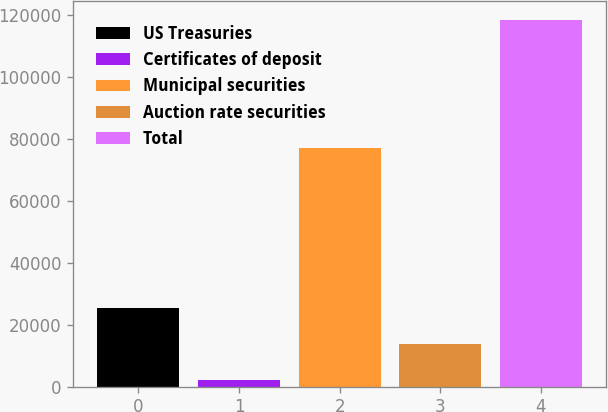<chart> <loc_0><loc_0><loc_500><loc_500><bar_chart><fcel>US Treasuries<fcel>Certificates of deposit<fcel>Municipal securities<fcel>Auction rate securities<fcel>Total<nl><fcel>25445.6<fcel>2201<fcel>77027<fcel>13823.3<fcel>118424<nl></chart> 